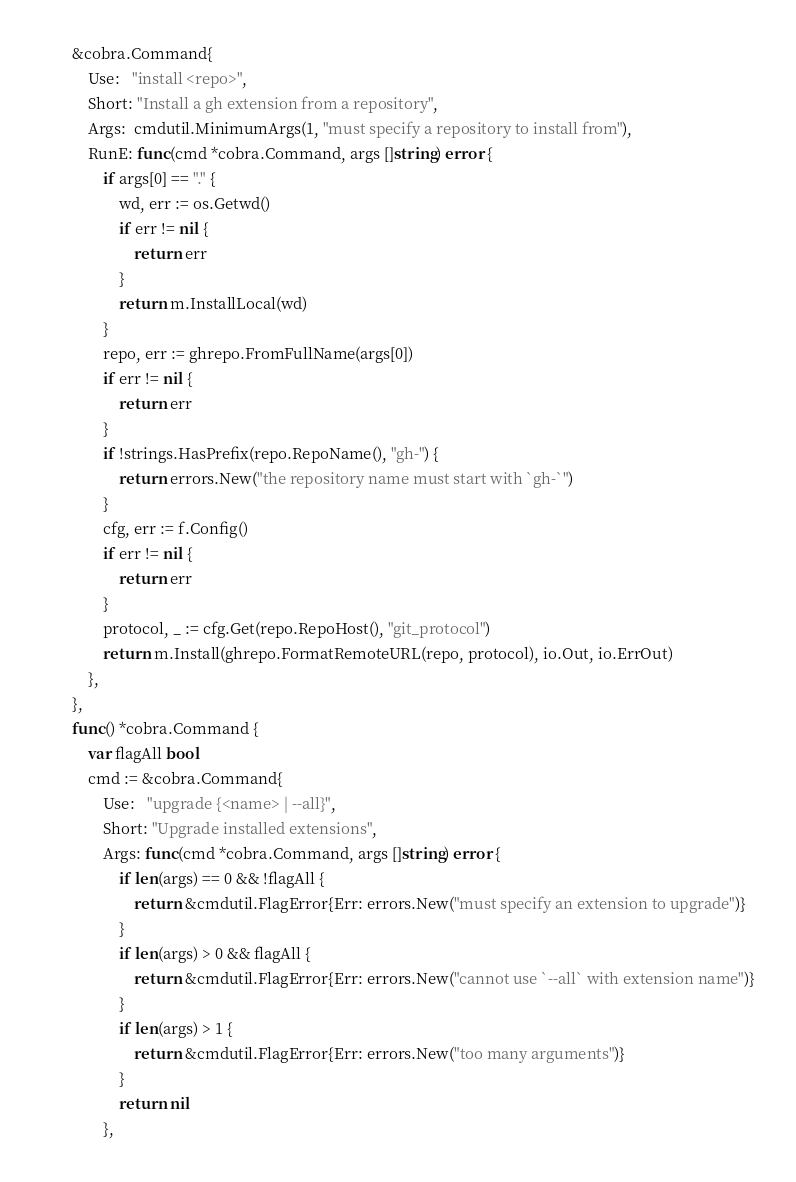<code> <loc_0><loc_0><loc_500><loc_500><_Go_>		&cobra.Command{
			Use:   "install <repo>",
			Short: "Install a gh extension from a repository",
			Args:  cmdutil.MinimumArgs(1, "must specify a repository to install from"),
			RunE: func(cmd *cobra.Command, args []string) error {
				if args[0] == "." {
					wd, err := os.Getwd()
					if err != nil {
						return err
					}
					return m.InstallLocal(wd)
				}
				repo, err := ghrepo.FromFullName(args[0])
				if err != nil {
					return err
				}
				if !strings.HasPrefix(repo.RepoName(), "gh-") {
					return errors.New("the repository name must start with `gh-`")
				}
				cfg, err := f.Config()
				if err != nil {
					return err
				}
				protocol, _ := cfg.Get(repo.RepoHost(), "git_protocol")
				return m.Install(ghrepo.FormatRemoteURL(repo, protocol), io.Out, io.ErrOut)
			},
		},
		func() *cobra.Command {
			var flagAll bool
			cmd := &cobra.Command{
				Use:   "upgrade {<name> | --all}",
				Short: "Upgrade installed extensions",
				Args: func(cmd *cobra.Command, args []string) error {
					if len(args) == 0 && !flagAll {
						return &cmdutil.FlagError{Err: errors.New("must specify an extension to upgrade")}
					}
					if len(args) > 0 && flagAll {
						return &cmdutil.FlagError{Err: errors.New("cannot use `--all` with extension name")}
					}
					if len(args) > 1 {
						return &cmdutil.FlagError{Err: errors.New("too many arguments")}
					}
					return nil
				},</code> 